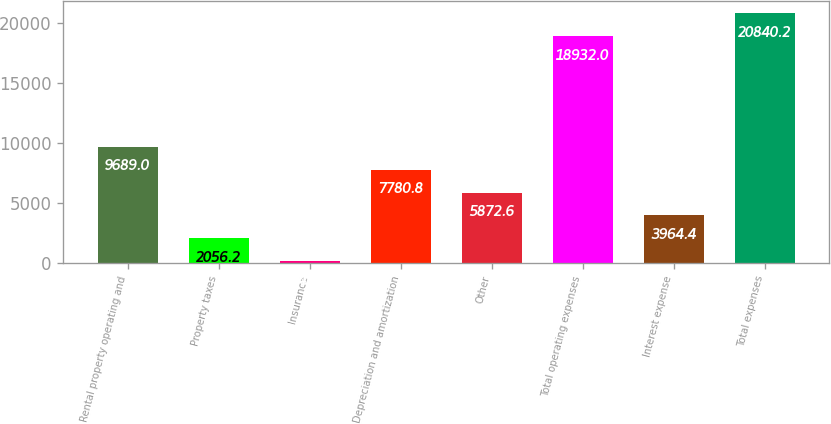Convert chart. <chart><loc_0><loc_0><loc_500><loc_500><bar_chart><fcel>Rental property operating and<fcel>Property taxes<fcel>Insurance<fcel>Depreciation and amortization<fcel>Other<fcel>Total operating expenses<fcel>Interest expense<fcel>Total expenses<nl><fcel>9689<fcel>2056.2<fcel>148<fcel>7780.8<fcel>5872.6<fcel>18932<fcel>3964.4<fcel>20840.2<nl></chart> 